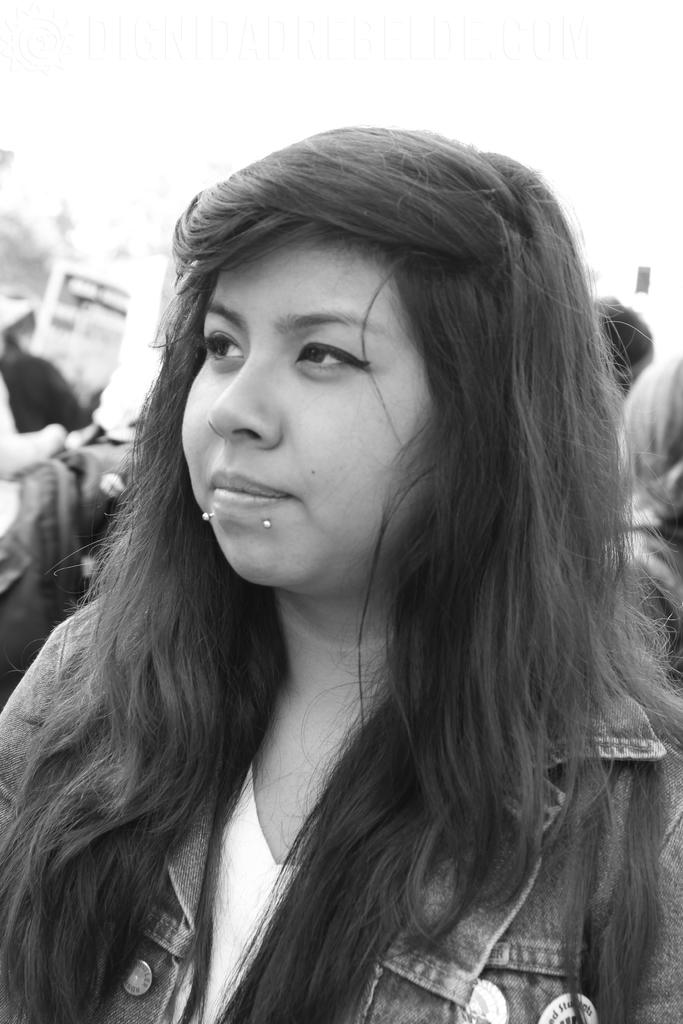What is the color scheme of the image? The image is black and white. Where was the image taken? The image was taken outdoors. Can you describe the background of the image? There are people in the background of the image. Who is the main subject in the image? There is a girl in the middle of the image. What is the girl wearing? The girl is wearing a jacket. What type of steel plate is being used to serve the stew in the image? There is no steel plate or stew present in the image. 